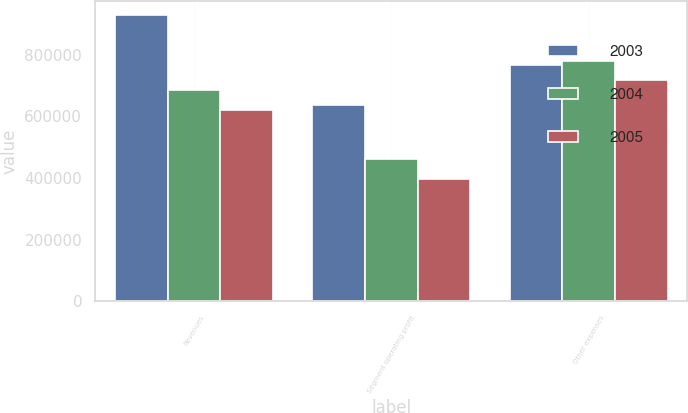<chart> <loc_0><loc_0><loc_500><loc_500><stacked_bar_chart><ecel><fcel>Revenues<fcel>Segment operating profit<fcel>Other expenses<nl><fcel>2003<fcel>929762<fcel>637846<fcel>768363<nl><fcel>2004<fcel>684422<fcel>461426<fcel>779000<nl><fcel>2005<fcel>619697<fcel>397239<fcel>718260<nl></chart> 